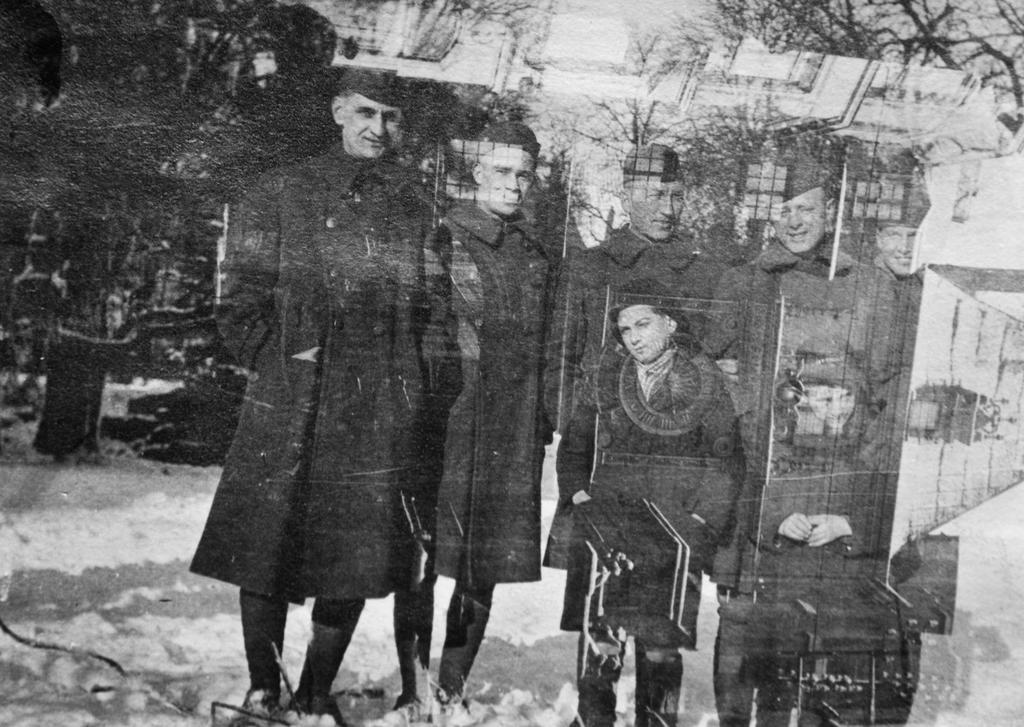What object is present in the image that can reflect images? There is a mirror in the image. What can be seen in the mirror? A group of people is reflected in the mirror. What type of natural scenery is visible in the image? There are trees visible in the image. What type of man-made structures can be seen in the image? There are buildings visible in the image. What is the weather like in the image? The presence of snow at the bottom of the image suggests a cold or wintery weather. What is visible at the top of the image? The sky is visible at the top of the image. What type of bomb can be seen in the image? There is no bomb present in the image. What type of soda is being served in the image? There is no soda present in the image. 